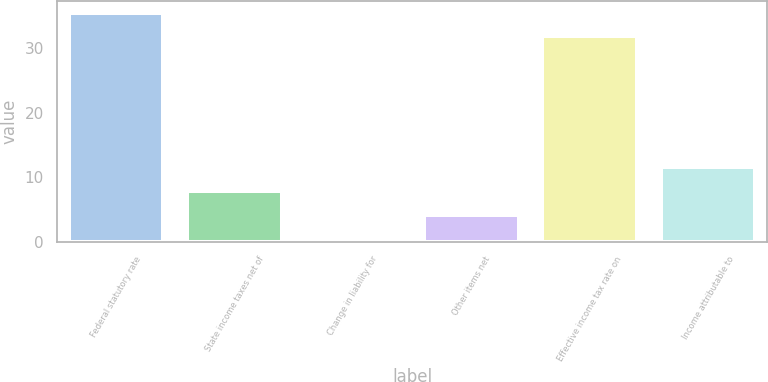Convert chart to OTSL. <chart><loc_0><loc_0><loc_500><loc_500><bar_chart><fcel>Federal statutory rate<fcel>State income taxes net of<fcel>Change in liability for<fcel>Other items net<fcel>Effective income tax rate on<fcel>Income attributable to<nl><fcel>35.47<fcel>7.84<fcel>0.5<fcel>4.17<fcel>31.8<fcel>11.51<nl></chart> 